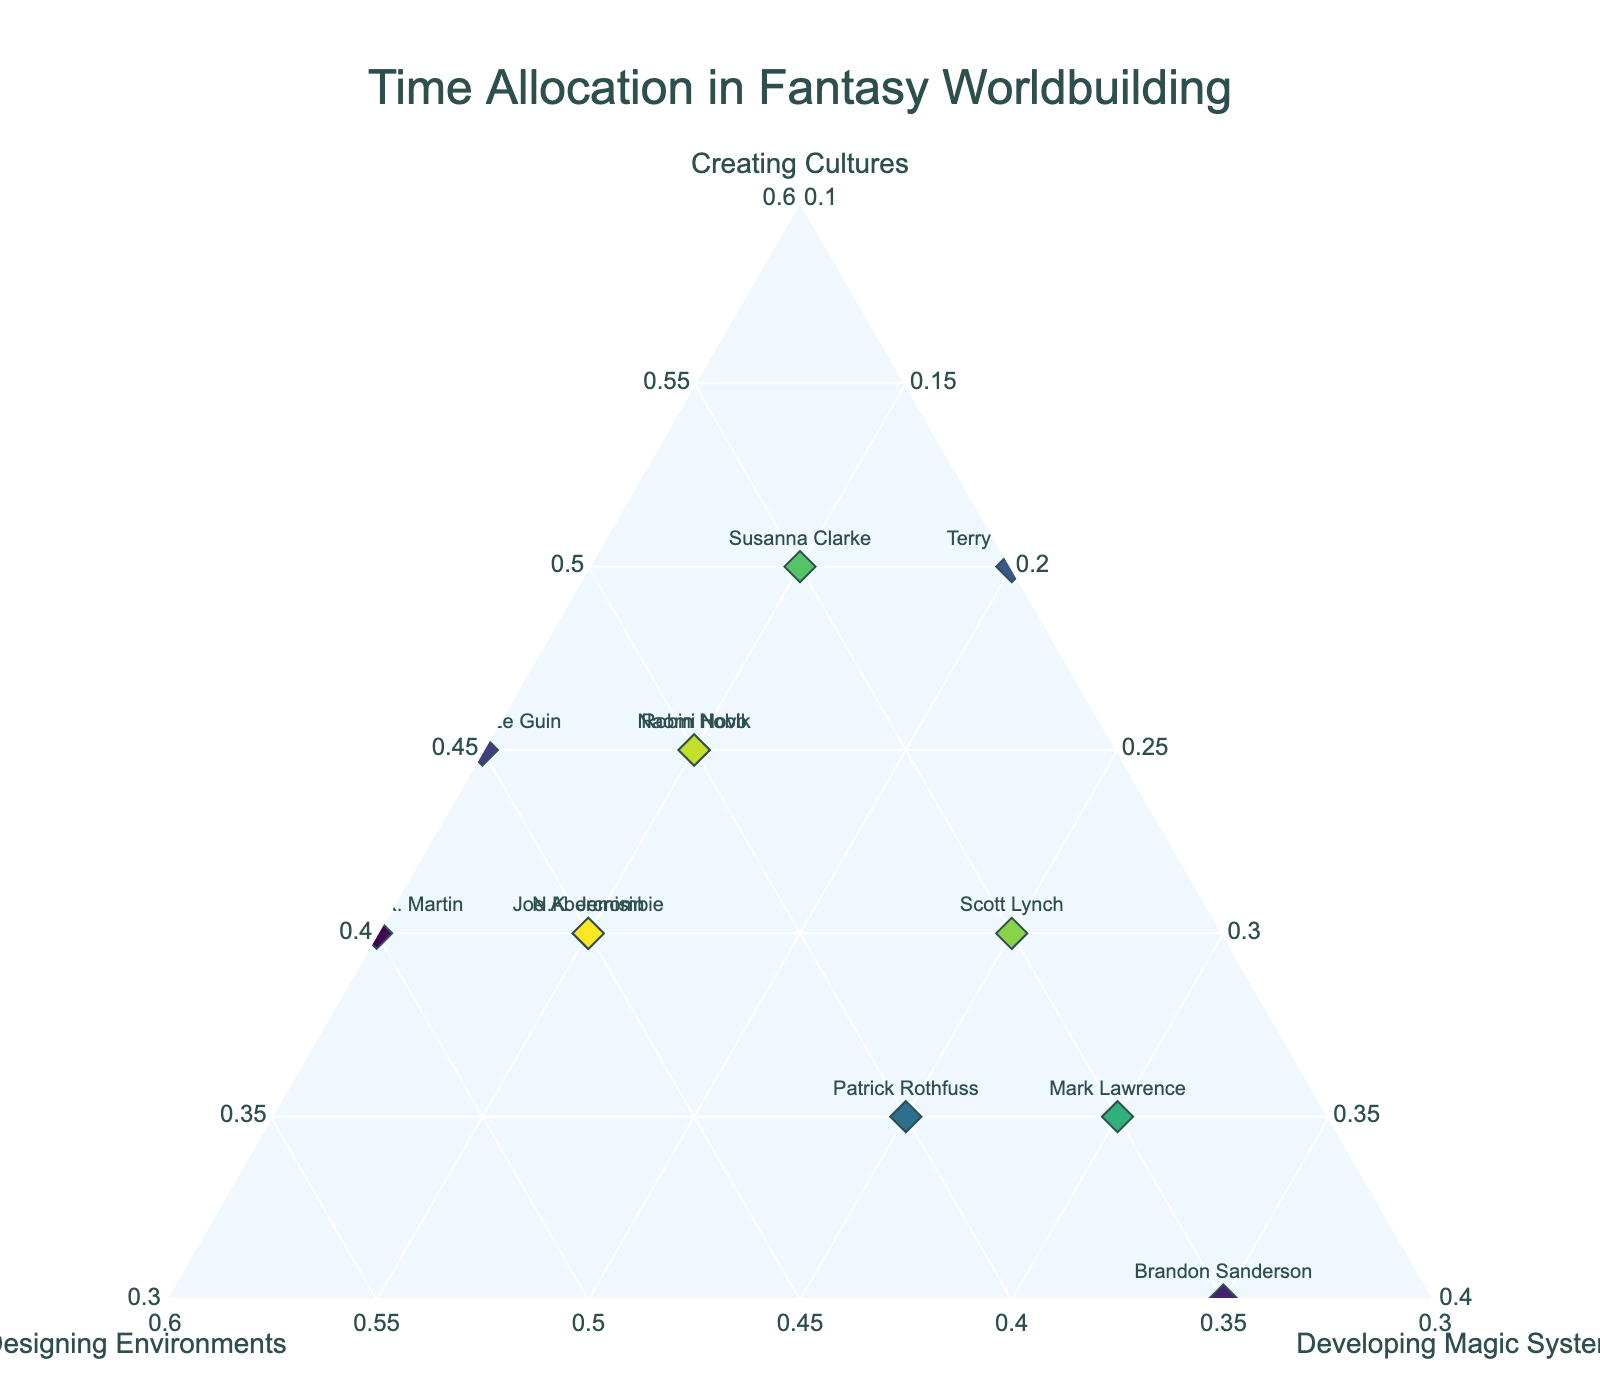What's the title of the figure? The title is clearly displayed at the top of the figure. It reads "Time Allocation in Fantasy Worldbuilding".
Answer: Time Allocation in Fantasy Worldbuilding Which author allocated the most time to creating cultures? By examining the points labeled by author names and their positions on the axis labeled "Creating Cultures", we see that Susanna Clarke and Terry Pratchett both have the highest value of 50%.
Answer: Susanna Clarke and Terry Pratchett What is the average percentage of time allocated to developing magic systems across all authors? Sum the "Developing Magic Systems" values for all authors and divide by the number of authors: (10 + 35 + 10 + 20 + 25 + 15 + 15 + 30 + 15 + 25 + 15 + 15) / 12 = 19.17 (rounded to two decimal places).
Answer: 19.17 Which authors have an equal distribution of time between designing environments and creating cultures? Look at the points where the percentages for "Creating Cultures" and "Designing Environments" are the same. Ursula K. Le Guin allocated 45% to both creating cultures and designing environments.
Answer: Ursula K. Le Guin Among the authors who spent 40% of their time on creating cultures, who allocated the least time to developing magic systems? Identify authors with 40% allocated to creating cultures (George R.R. Martin, Scott Lynch, N.K. Jemisin, Joe Abercrombie). Among them, George R.R. Martin allocated the least to developing magic systems at 10%.
Answer: George R.R. Martin How many data points are represented in the plot? Each author represents one data point in the ternary plot. There are 12 authors, so there are 12 data points.
Answer: 12 Which author allocated an equal amount of time among all three activities? Look for an author whose point in the ternary plot lies equidistant from all three axes. Brandon Sanderson allocated time equally, with 30% for creating cultures, 35% for designing environments, and 35% for developing magic systems.
Answer: Brandon Sanderson Who spends more time designing environments, Ursula K. Le Guin or Robin Hobb? By checking the values on the "Designing Environments" axis, Ursula K. Le Guin and Robin Hobb both have 45% and 40% respectively, so Ursula K. Le Guin spends more time.
Answer: Ursula K. Le Guin Which author allocated the highest percentage of their time to developing magic systems? On the axis labeled "Developing Magic Systems", the highest percentage (35%) belongs to Brandon Sanderson.
Answer: Brandon Sanderson Which author has the most balanced time allocation among the three activities? A balanced allocation means the three percentages are closest to each other. Brandon Sanderson has allocation values that are closest (30%, 35%, 35%).
Answer: Brandon Sanderson 